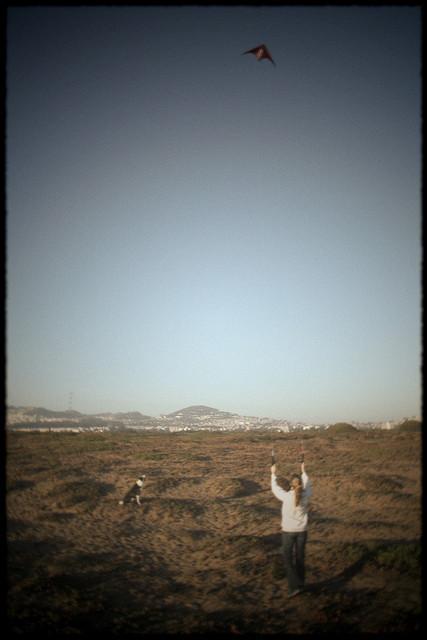How many dogs are seen?
Give a very brief answer. 1. How many people are there?
Give a very brief answer. 1. How many boats are in the picture?
Give a very brief answer. 0. 